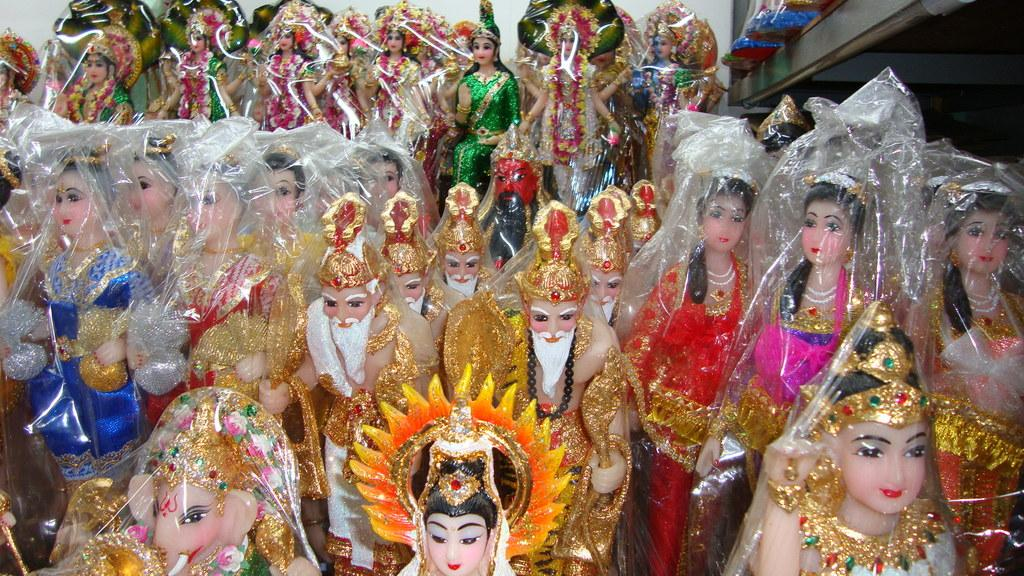What is present in the image? There are idols in the image. How are the idols being stored or transported? The idols are packed in plastic bags. What can be observed about the appearance of the idols? The idols are colored with different colors. What type of oatmeal is being served in the image? There is no oatmeal present in the image; it features idols packed in plastic bags. 